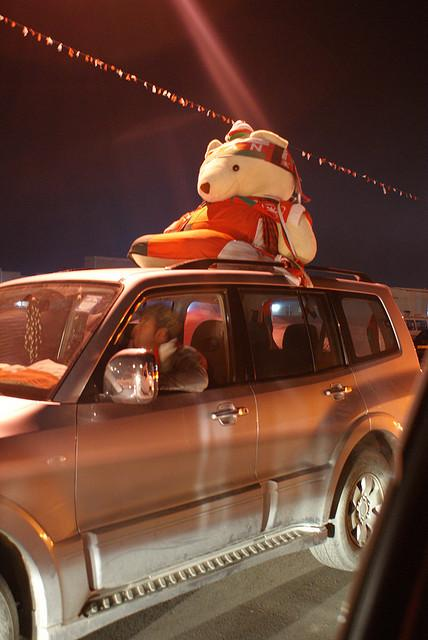What country is the scene located at?

Choices:
A) japan
B) iran
C) thailand
D) china japan 